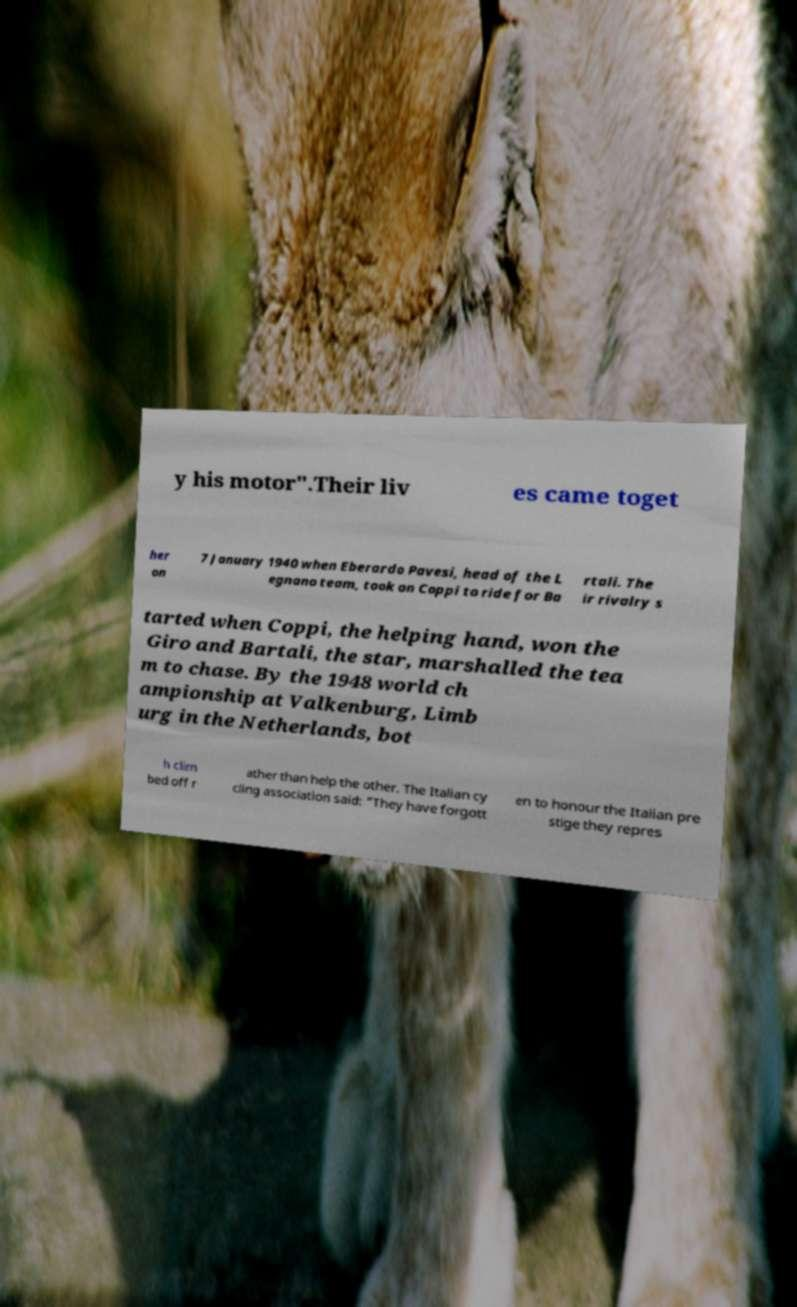What messages or text are displayed in this image? I need them in a readable, typed format. y his motor".Their liv es came toget her on 7 January 1940 when Eberardo Pavesi, head of the L egnano team, took on Coppi to ride for Ba rtali. The ir rivalry s tarted when Coppi, the helping hand, won the Giro and Bartali, the star, marshalled the tea m to chase. By the 1948 world ch ampionship at Valkenburg, Limb urg in the Netherlands, bot h clim bed off r ather than help the other. The Italian cy cling association said: "They have forgott en to honour the Italian pre stige they repres 